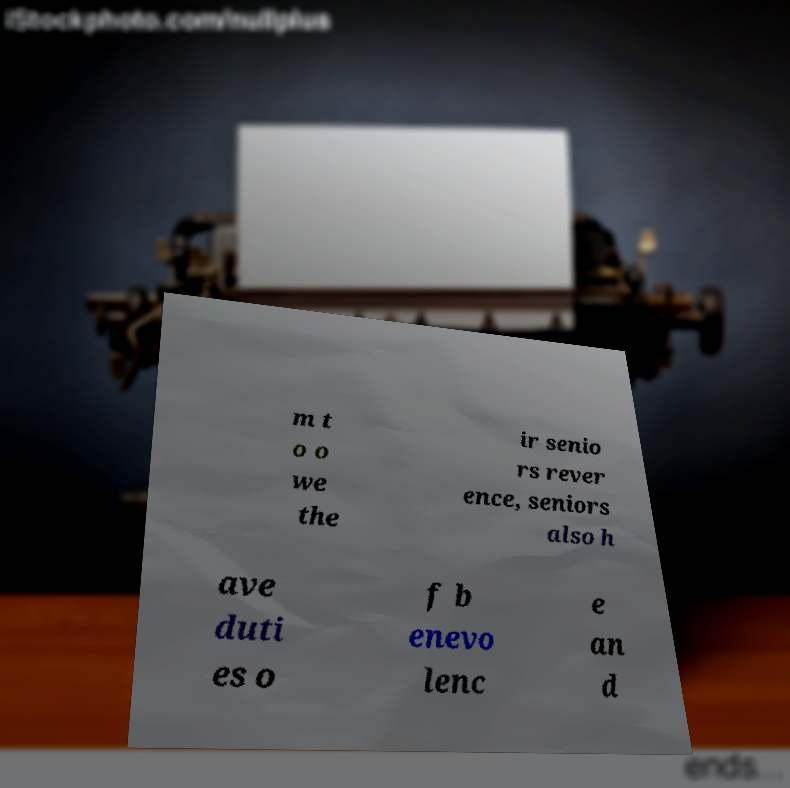Can you read and provide the text displayed in the image?This photo seems to have some interesting text. Can you extract and type it out for me? m t o o we the ir senio rs rever ence, seniors also h ave duti es o f b enevo lenc e an d 